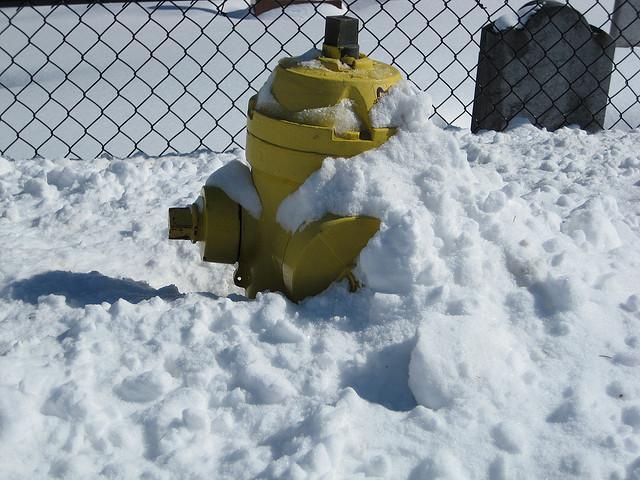Was this picture taken during the winter?
Be succinct. Yes. Is there a cemetery on the other side of the fence?
Concise answer only. Yes. Could fireman attach their hose without shoveling snow?
Write a very short answer. No. 